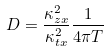<formula> <loc_0><loc_0><loc_500><loc_500>D = \frac { \kappa ^ { 2 } _ { z x } } { \kappa ^ { 2 } _ { t x } } \frac { 1 } { 4 \pi T } \,</formula> 